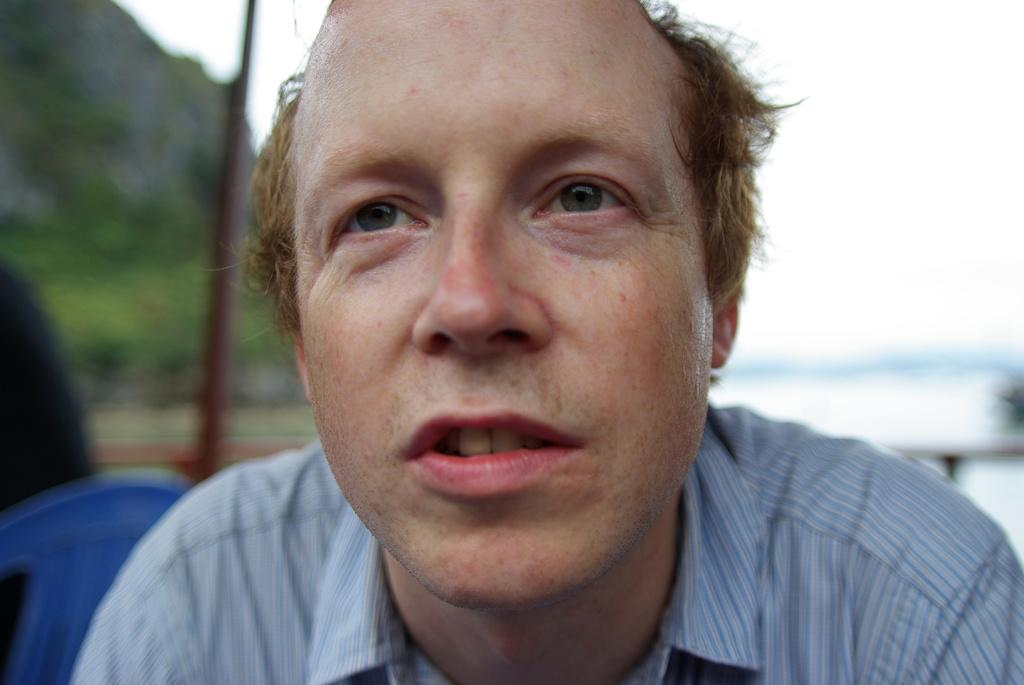What is the person in the image wearing? The person in the image is wearing a blue dress. What can be seen to the left of the person? There is a blue chair to the left of the person. Can you describe the background of the image? The background of the image is blurred. Where is the faucet located in the image? There is no faucet present in the image. What type of snake can be seen slithering in the background of the image? There is no snake present in the image; the background is blurred. 